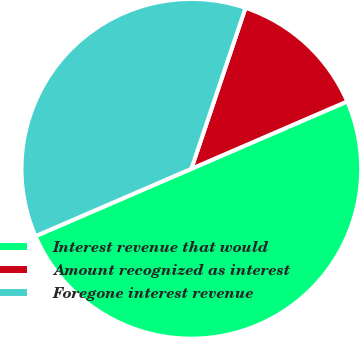Convert chart. <chart><loc_0><loc_0><loc_500><loc_500><pie_chart><fcel>Interest revenue that would<fcel>Amount recognized as interest<fcel>Foregone interest revenue<nl><fcel>50.0%<fcel>13.34%<fcel>36.66%<nl></chart> 